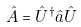<formula> <loc_0><loc_0><loc_500><loc_500>\hat { A } = \hat { U } ^ { \dagger } \hat { a } \hat { U }</formula> 